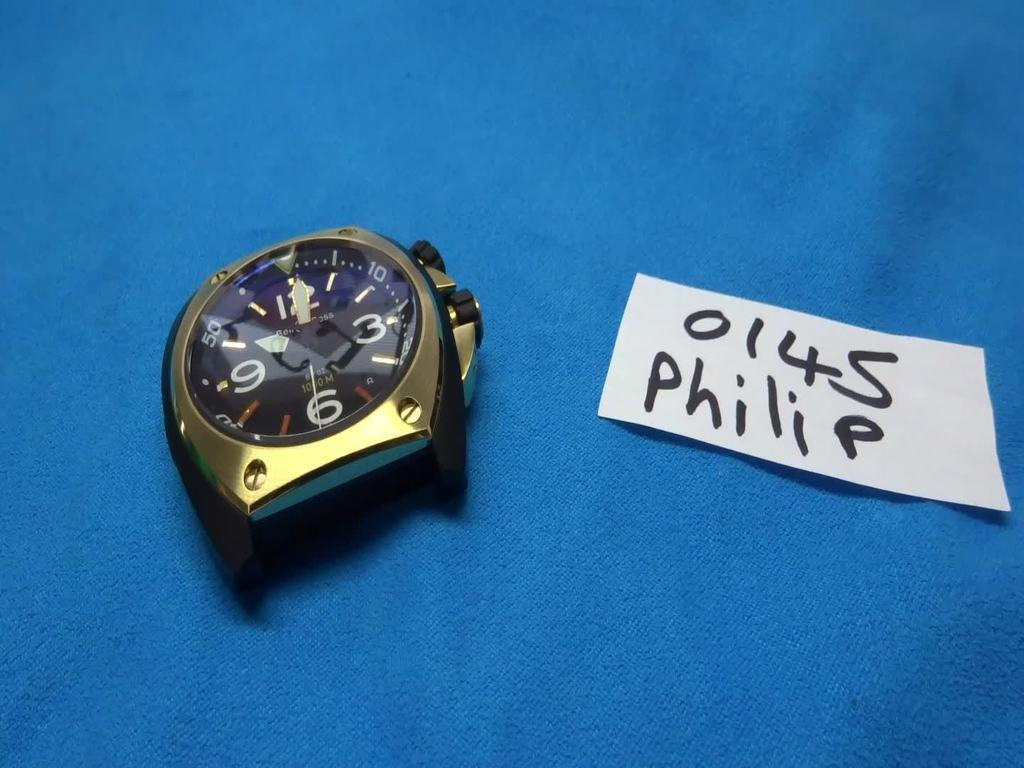<image>
Share a concise interpretation of the image provided. A watch sits near a little white card with the name Philip on it. 